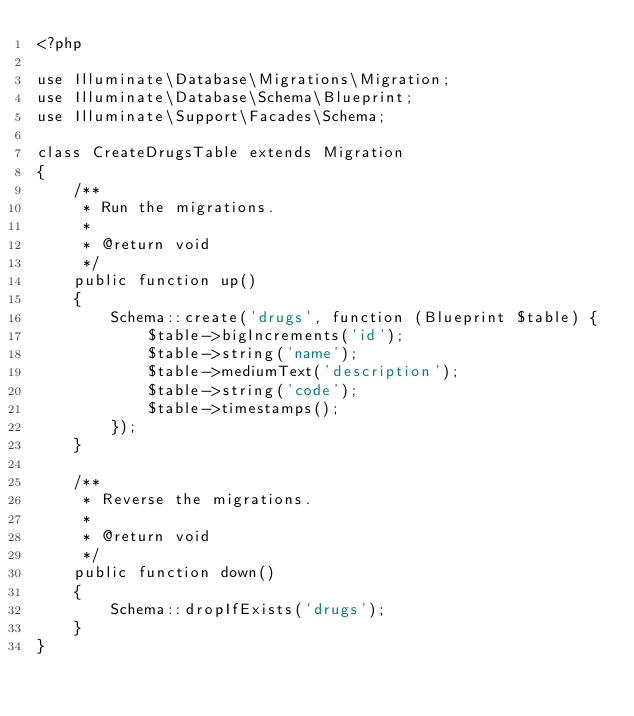Convert code to text. <code><loc_0><loc_0><loc_500><loc_500><_PHP_><?php

use Illuminate\Database\Migrations\Migration;
use Illuminate\Database\Schema\Blueprint;
use Illuminate\Support\Facades\Schema;

class CreateDrugsTable extends Migration
{
    /**
     * Run the migrations.
     *
     * @return void
     */
    public function up()
    {
        Schema::create('drugs', function (Blueprint $table) {
            $table->bigIncrements('id');
            $table->string('name');
            $table->mediumText('description');
            $table->string('code');
            $table->timestamps();
        });
    }

    /**
     * Reverse the migrations.
     *
     * @return void
     */
    public function down()
    {
        Schema::dropIfExists('drugs');
    }
}
</code> 